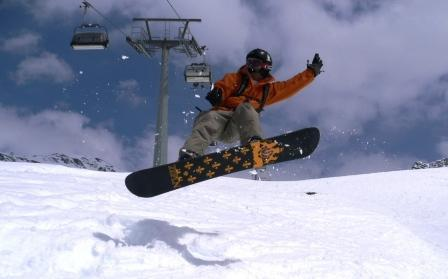What use would sitting in the seats have? Please explain your reasoning. up/downhill transport. The seats can go up and down the mountain. 